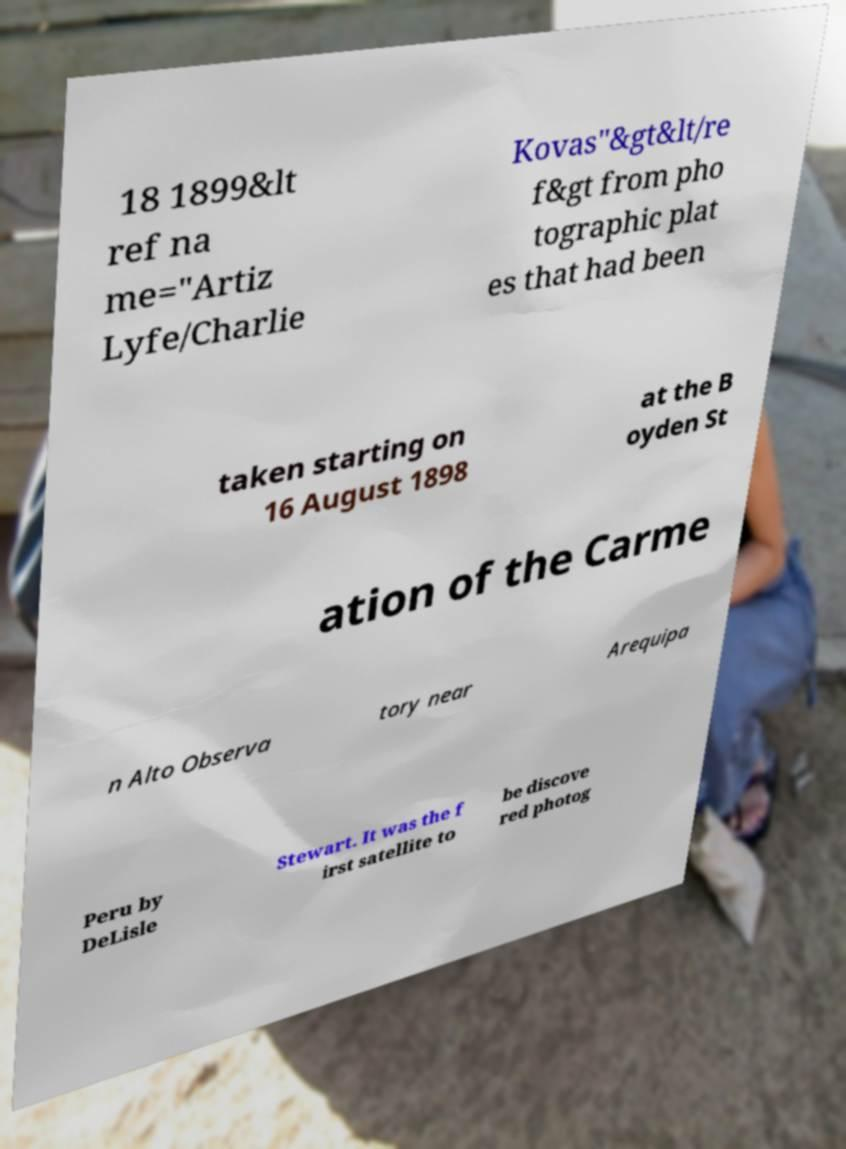For documentation purposes, I need the text within this image transcribed. Could you provide that? 18 1899&lt ref na me="Artiz Lyfe/Charlie Kovas"&gt&lt/re f&gt from pho tographic plat es that had been taken starting on 16 August 1898 at the B oyden St ation of the Carme n Alto Observa tory near Arequipa Peru by DeLisle Stewart. It was the f irst satellite to be discove red photog 